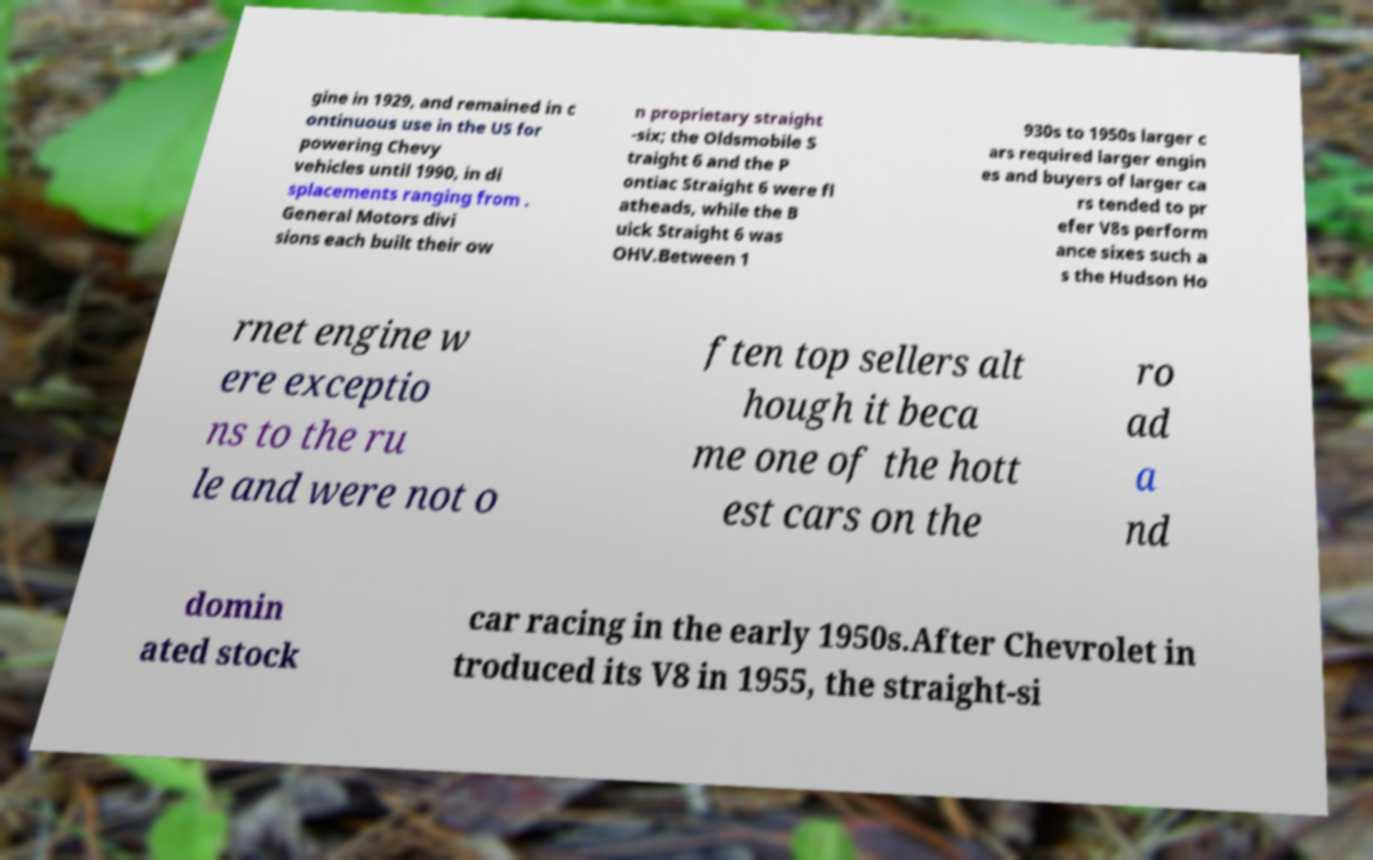What messages or text are displayed in this image? I need them in a readable, typed format. gine in 1929, and remained in c ontinuous use in the US for powering Chevy vehicles until 1990, in di splacements ranging from . General Motors divi sions each built their ow n proprietary straight -six; the Oldsmobile S traight 6 and the P ontiac Straight 6 were fl atheads, while the B uick Straight 6 was OHV.Between 1 930s to 1950s larger c ars required larger engin es and buyers of larger ca rs tended to pr efer V8s perform ance sixes such a s the Hudson Ho rnet engine w ere exceptio ns to the ru le and were not o ften top sellers alt hough it beca me one of the hott est cars on the ro ad a nd domin ated stock car racing in the early 1950s.After Chevrolet in troduced its V8 in 1955, the straight-si 